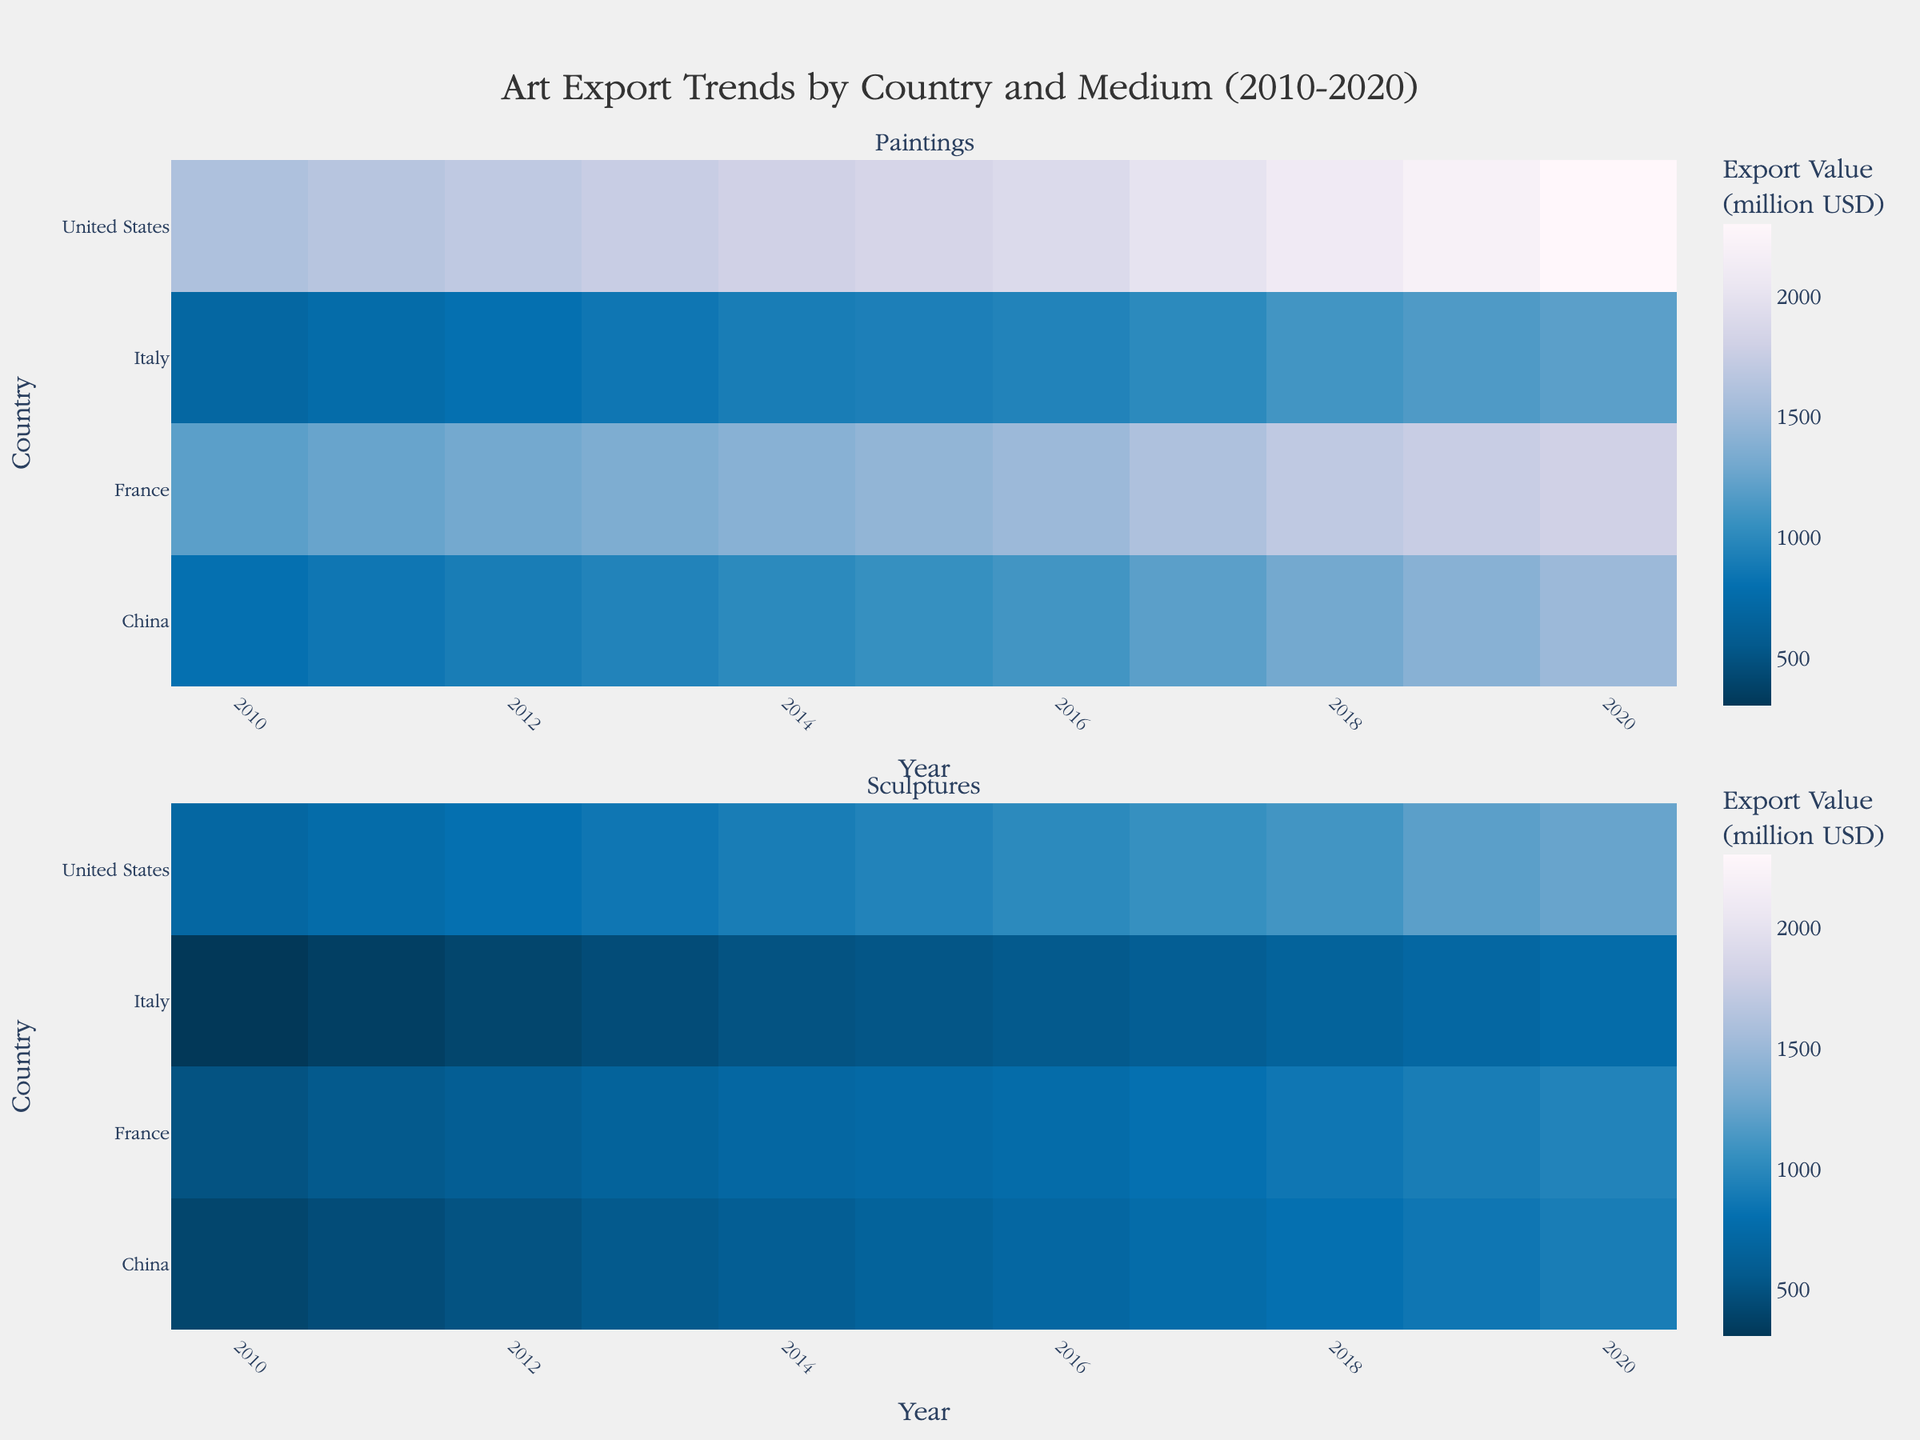What is the title of the Heatmap? The title of any plot or heatmap is usually written at the top center of the figure. In this case, the title is given as "Art Export Trends by Country and Medium (2010-2020)."
Answer: Art Export Trends by Country and Medium (2010-2020) Which country had the highest export value for paintings in 2020? To find which country had the highest export value for paintings in 2020, look at the section of the heatmap dedicated to paintings and identify the country with the darkest color in the year 2020. The darkest color corresponds to the highest export value.
Answer: United States How did France's export value for sculptures change from 2010 to 2020? To determine how France's export value for sculptures changed from 2010 to 2020, observe the color gradient for France in the section of the heatmap for sculptures between these years. France's export value for sculptures becomes darker, indicating an increase.
Answer: Increased Compare the export values of paintings between China and Italy in 2016. Which country had a higher export value? To compare, look at the two countries' corresponding rows in the heatmap section for paintings, specifically under the column for the year 2016. Note the difference in color intensity where a darker color indicates a higher export value.
Answer: China What was the trend in the export value for sculptures in the United States from 2010 to 2020? To determine the trend for the United States' sculpture exports, observe the row representing the United States under the sculptures section from 2010 to 2020. The consistent darkening over the years indicates a continuous upward trend.
Answer: Upward trend Which medium showed the highest increase in export value in Italy from 2010 to 2020? To determine the highest increase in export value in Italy, compare the change in color intensity from 2010 to 2020 in both the paintings and sculptures sections. The medium with the more significant change (most pronounced darkening) signifies the highest increase.
Answer: Paintings On average, which country showed a higher export value for paintings over the entire period: France or Italy? To determine this, compare the average color intensity for France and Italy in the paintings section over the period from 2010 to 2020. France's row is generally darker than Italy's, indicating higher average export values.
Answer: France In which year did China surpass the export value of 1000 million USD for paintings, according to the heatmap? Find the first year in the paintings section for China where the color intensity reaches a shade corresponding to a value over 1000 million USD.
Answer: 2015 What is the difference in the 2020 export value for sculptures between the United States and Italy? To find the difference, locate the values for sculptures in 2020 for both countries and subtract Italy's value from the United States' value. The heatmap color shades for these values help estimate the difference. United States (1250 million) - Italy (750 million) = 500 million
Answer: 500 million Which country among those listed showed the smallest change in export value for any medium from 2010 to 2020? Identify the country that shows the least change in color intensity between 2010 and 2020 for either medium. This country will have the most consistent coloring in its rows for paintings or sculptures.
Answer: Italy (Sculptures) 